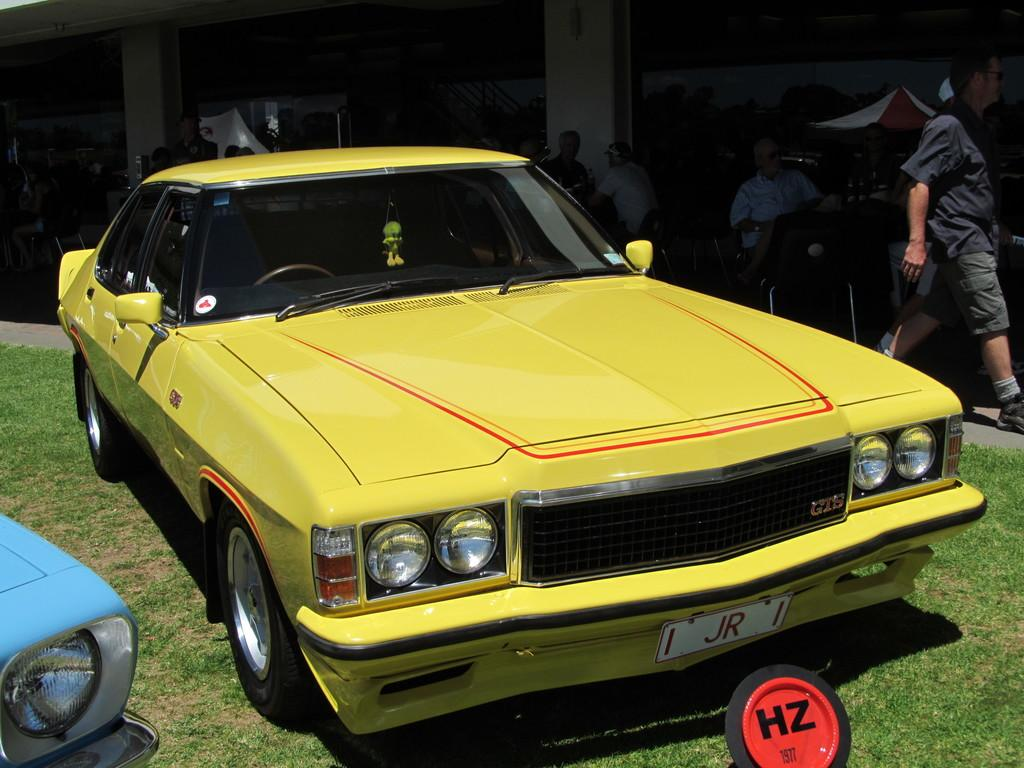What can be seen on the ground in the image? There are cars on the ground in the image. What are the people doing near the cars? The people are sitting on chairs beside the cars. What structure is visible in the background of the image? There is a building visible at the back side of the image. Can you describe the thickness of the fog in the image? There is no fog present in the image; it features cars, people sitting on chairs, and a building in the background. What type of ornament is hanging from the car's rearview mirror in the image? There is no ornament mentioned or visible in the image. 